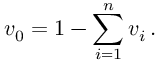Convert formula to latex. <formula><loc_0><loc_0><loc_500><loc_500>v _ { 0 } = 1 - \sum _ { i = 1 } ^ { n } v _ { i } \, .</formula> 